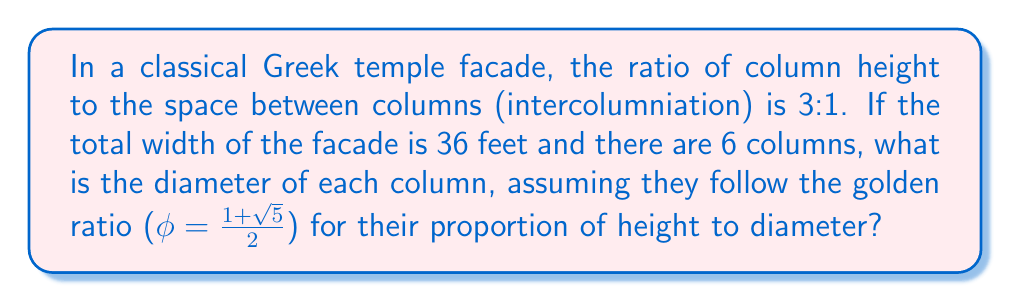What is the answer to this math problem? Let's approach this step-by-step:

1) First, let's define variables:
   $w$ = total width of facade = 36 feet
   $n$ = number of columns = 6
   $h$ = height of column
   $d$ = diameter of column
   $s$ = space between columns (intercolumniation)

2) We know that $h:s = 3:1$, so $s = \frac{h}{3}$

3) The total width consists of column diameters and spaces:
   $w = nd + (n-1)s$
   $36 = 6d + 5s$

4) We also know that $h:d = \phi:1$, where $\phi = \frac{1+\sqrt{5}}{2}$
   So, $h = \phi d$

5) Substituting $h$ into the equation for $s$:
   $s = \frac{h}{3} = \frac{\phi d}{3}$

6) Now we can substitute this into our width equation:
   $36 = 6d + 5(\frac{\phi d}{3})$

7) Simplify:
   $36 = 6d + \frac{5\phi d}{3}$
   $108 = 18d + 5\phi d$
   $108 = d(18 + 5\phi)$

8) Solve for $d$:
   $d = \frac{108}{18 + 5\phi}$

9) Substitute the value of $\phi$:
   $d = \frac{108}{18 + 5(\frac{1+\sqrt{5}}{2})}$

10) Simplify:
    $d = \frac{108}{18 + \frac{5+5\sqrt{5}}{2}} = \frac{108}{20.5 + 2.5\sqrt{5}} \approx 2.69$ feet
Answer: $2.69$ feet 